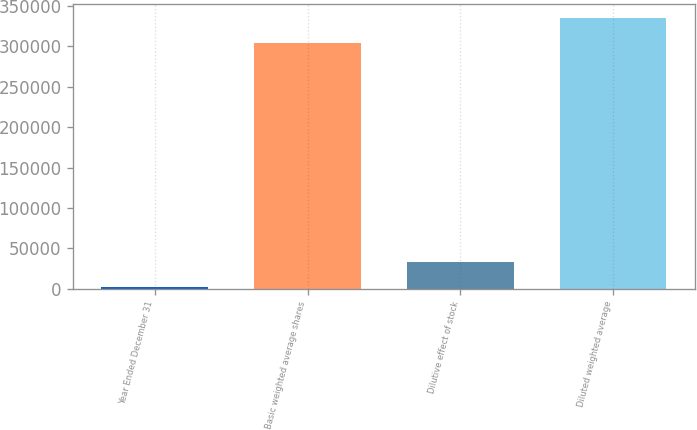Convert chart. <chart><loc_0><loc_0><loc_500><loc_500><bar_chart><fcel>Year Ended December 31<fcel>Basic weighted average shares<fcel>Dilutive effect of stock<fcel>Diluted weighted average<nl><fcel>2016<fcel>304707<fcel>32853.1<fcel>335544<nl></chart> 